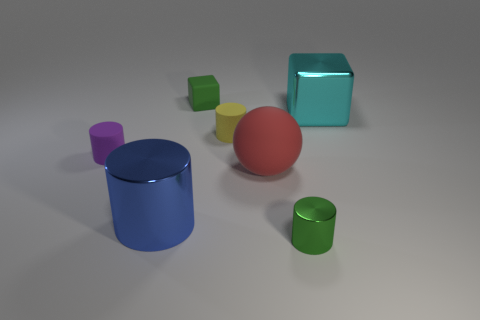Subtract all green metallic cylinders. How many cylinders are left? 3 Subtract all yellow cylinders. How many cylinders are left? 3 Add 2 tiny metal balls. How many objects exist? 9 Subtract all cubes. How many objects are left? 5 Subtract all green shiny objects. Subtract all cyan things. How many objects are left? 5 Add 6 blue cylinders. How many blue cylinders are left? 7 Add 1 cyan objects. How many cyan objects exist? 2 Subtract 0 gray balls. How many objects are left? 7 Subtract all blue cylinders. Subtract all purple balls. How many cylinders are left? 3 